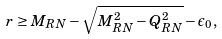<formula> <loc_0><loc_0><loc_500><loc_500>r \geq M _ { R N } - \sqrt { M ^ { 2 } _ { R N } - Q ^ { 2 } _ { R N } } - \epsilon _ { 0 } ,</formula> 